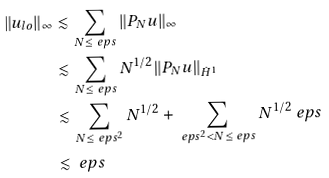Convert formula to latex. <formula><loc_0><loc_0><loc_500><loc_500>\| u _ { l o } \| _ { \infty } & \lesssim \sum _ { N \leq \ e p s } \| P _ { N } u \| _ { \infty } \\ & \lesssim \sum _ { N \leq \ e p s } N ^ { 1 / 2 } \| P _ { N } u \| _ { \dot { H } ^ { 1 } } \\ & \lesssim \sum _ { N \leq \ e p s ^ { 2 } } N ^ { 1 / 2 } + \sum _ { \ e p s ^ { 2 } < N \leq \ e p s } N ^ { 1 / 2 } \ e p s \\ & \lesssim \ e p s</formula> 